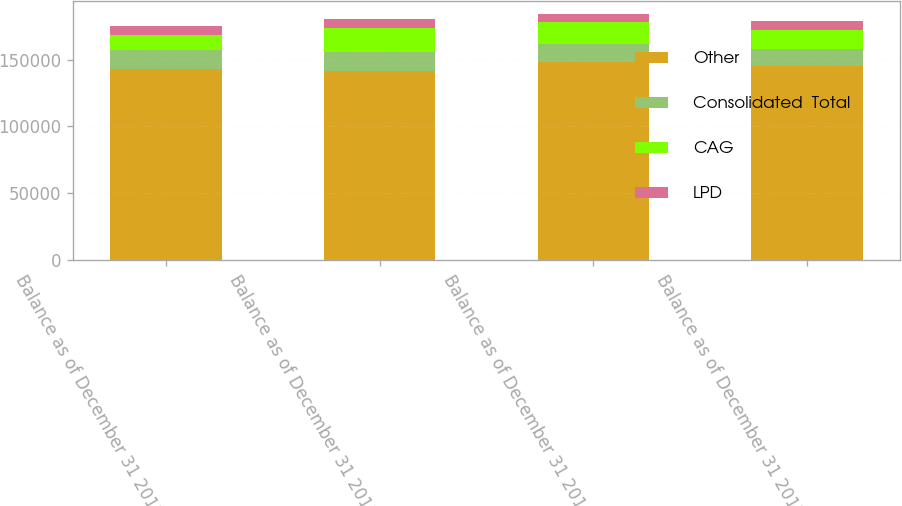Convert chart. <chart><loc_0><loc_0><loc_500><loc_500><stacked_bar_chart><ecel><fcel>Balance as of December 31 2012<fcel>Balance as of December 31 2013<fcel>Balance as of December 31 2014<fcel>Balance as of December 31 2015<nl><fcel>Other<fcel>143155<fcel>141408<fcel>148151<fcel>145191<nl><fcel>Consolidated  Total<fcel>14179<fcel>14515<fcel>13689<fcel>13038<nl><fcel>CAG<fcel>11129<fcel>18067<fcel>16079<fcel>14174<nl><fcel>LPD<fcel>6531<fcel>6531<fcel>6531<fcel>6531<nl></chart> 